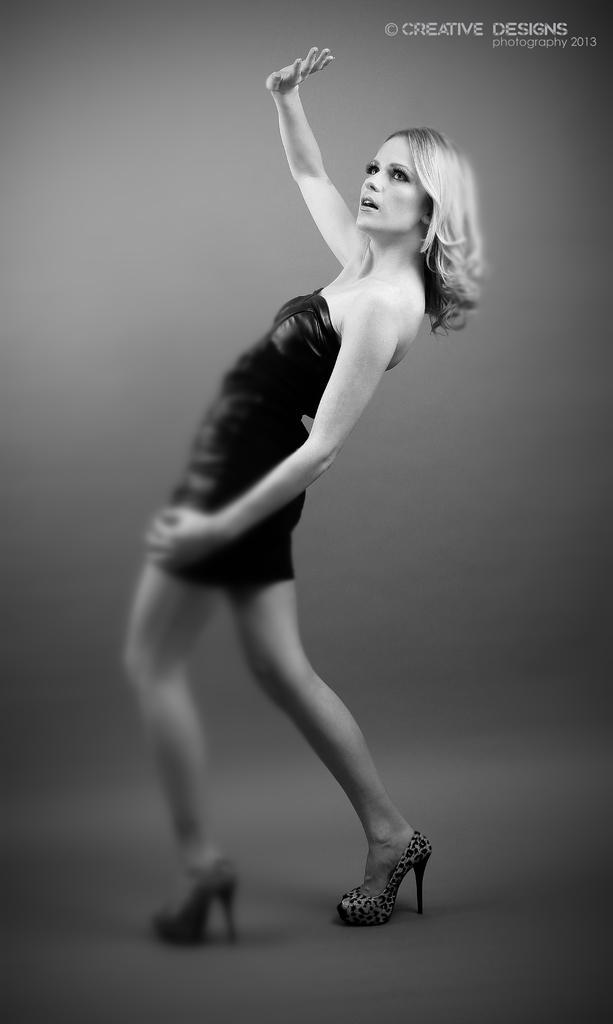Could you give a brief overview of what you see in this image? In this picture I can observe a woman standing on the floor. This is black and white image. On the top right side I can observe some text. 